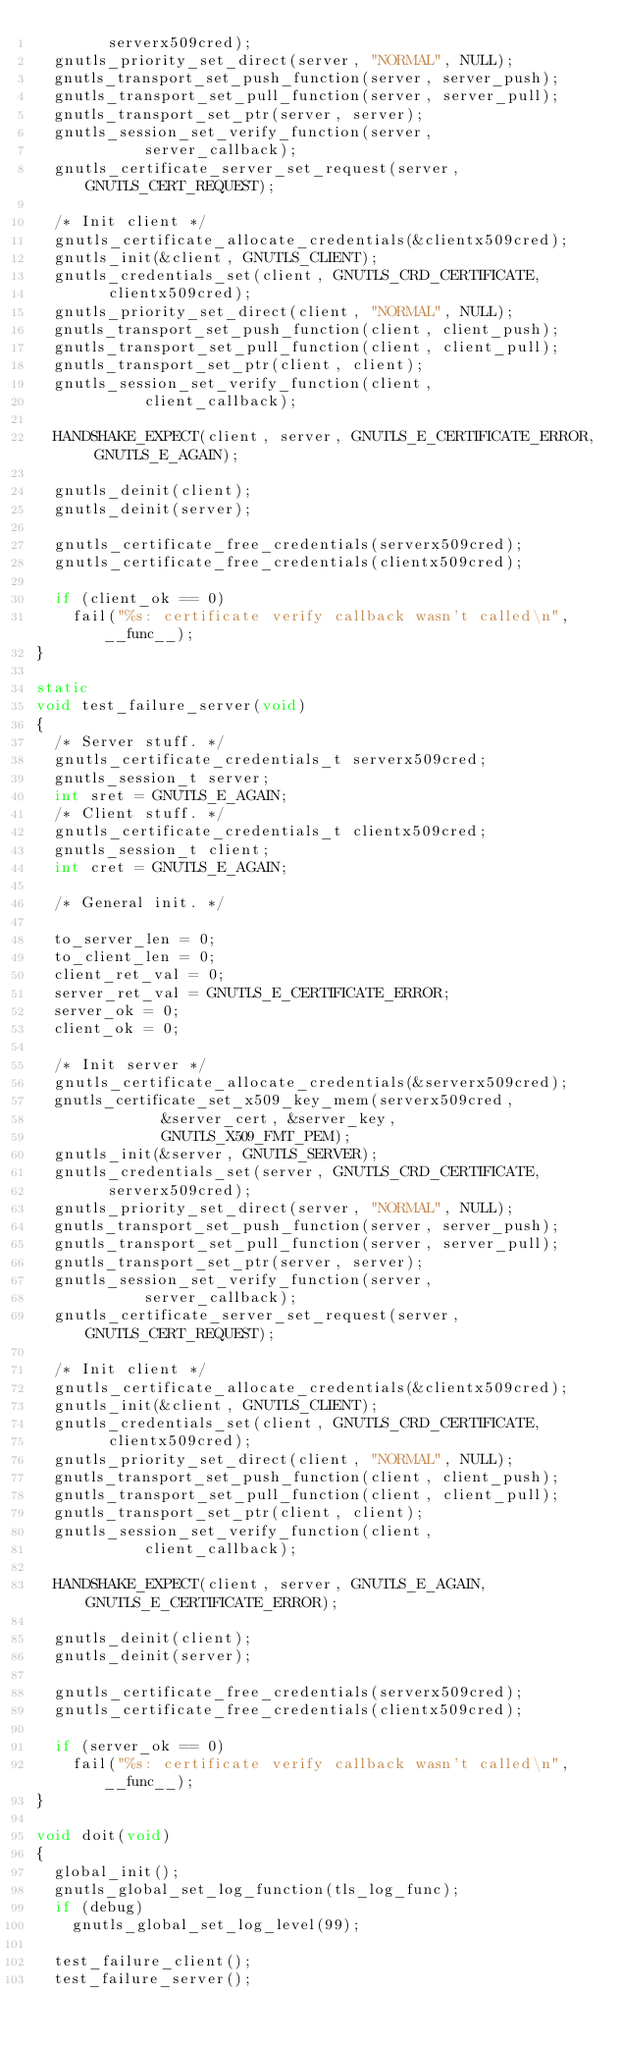<code> <loc_0><loc_0><loc_500><loc_500><_C_>				serverx509cred);
	gnutls_priority_set_direct(server, "NORMAL", NULL);
	gnutls_transport_set_push_function(server, server_push);
	gnutls_transport_set_pull_function(server, server_pull);
	gnutls_transport_set_ptr(server, server);
	gnutls_session_set_verify_function(server,
						server_callback);
	gnutls_certificate_server_set_request(server, GNUTLS_CERT_REQUEST);

	/* Init client */
	gnutls_certificate_allocate_credentials(&clientx509cred);
	gnutls_init(&client, GNUTLS_CLIENT);
	gnutls_credentials_set(client, GNUTLS_CRD_CERTIFICATE,
				clientx509cred);
	gnutls_priority_set_direct(client, "NORMAL", NULL);
	gnutls_transport_set_push_function(client, client_push);
	gnutls_transport_set_pull_function(client, client_pull);
	gnutls_transport_set_ptr(client, client);
	gnutls_session_set_verify_function(client,
						client_callback);

	HANDSHAKE_EXPECT(client, server, GNUTLS_E_CERTIFICATE_ERROR, GNUTLS_E_AGAIN);

	gnutls_deinit(client);
	gnutls_deinit(server);

	gnutls_certificate_free_credentials(serverx509cred);
	gnutls_certificate_free_credentials(clientx509cred);

	if (client_ok == 0)
		fail("%s: certificate verify callback wasn't called\n", __func__);
}

static
void test_failure_server(void)
{
	/* Server stuff. */
	gnutls_certificate_credentials_t serverx509cred;
	gnutls_session_t server;
	int sret = GNUTLS_E_AGAIN;
	/* Client stuff. */
	gnutls_certificate_credentials_t clientx509cred;
	gnutls_session_t client;
	int cret = GNUTLS_E_AGAIN;

	/* General init. */

	to_server_len = 0;
	to_client_len = 0;
	client_ret_val = 0;
	server_ret_val = GNUTLS_E_CERTIFICATE_ERROR;
	server_ok = 0;
	client_ok = 0;

	/* Init server */
	gnutls_certificate_allocate_credentials(&serverx509cred);
	gnutls_certificate_set_x509_key_mem(serverx509cred,
					    &server_cert, &server_key,
					    GNUTLS_X509_FMT_PEM);
	gnutls_init(&server, GNUTLS_SERVER);
	gnutls_credentials_set(server, GNUTLS_CRD_CERTIFICATE,
				serverx509cred);
	gnutls_priority_set_direct(server, "NORMAL", NULL);
	gnutls_transport_set_push_function(server, server_push);
	gnutls_transport_set_pull_function(server, server_pull);
	gnutls_transport_set_ptr(server, server);
	gnutls_session_set_verify_function(server,
						server_callback);
	gnutls_certificate_server_set_request(server, GNUTLS_CERT_REQUEST);

	/* Init client */
	gnutls_certificate_allocate_credentials(&clientx509cred);
	gnutls_init(&client, GNUTLS_CLIENT);
	gnutls_credentials_set(client, GNUTLS_CRD_CERTIFICATE,
				clientx509cred);
	gnutls_priority_set_direct(client, "NORMAL", NULL);
	gnutls_transport_set_push_function(client, client_push);
	gnutls_transport_set_pull_function(client, client_pull);
	gnutls_transport_set_ptr(client, client);
	gnutls_session_set_verify_function(client,
						client_callback);

	HANDSHAKE_EXPECT(client, server, GNUTLS_E_AGAIN, GNUTLS_E_CERTIFICATE_ERROR);

	gnutls_deinit(client);
	gnutls_deinit(server);

	gnutls_certificate_free_credentials(serverx509cred);
	gnutls_certificate_free_credentials(clientx509cred);

	if (server_ok == 0)
		fail("%s: certificate verify callback wasn't called\n", __func__);
}

void doit(void)
{
	global_init();
	gnutls_global_set_log_function(tls_log_func);
	if (debug)
		gnutls_global_set_log_level(99);

	test_failure_client();
	test_failure_server();</code> 